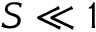<formula> <loc_0><loc_0><loc_500><loc_500>S \ll 1</formula> 